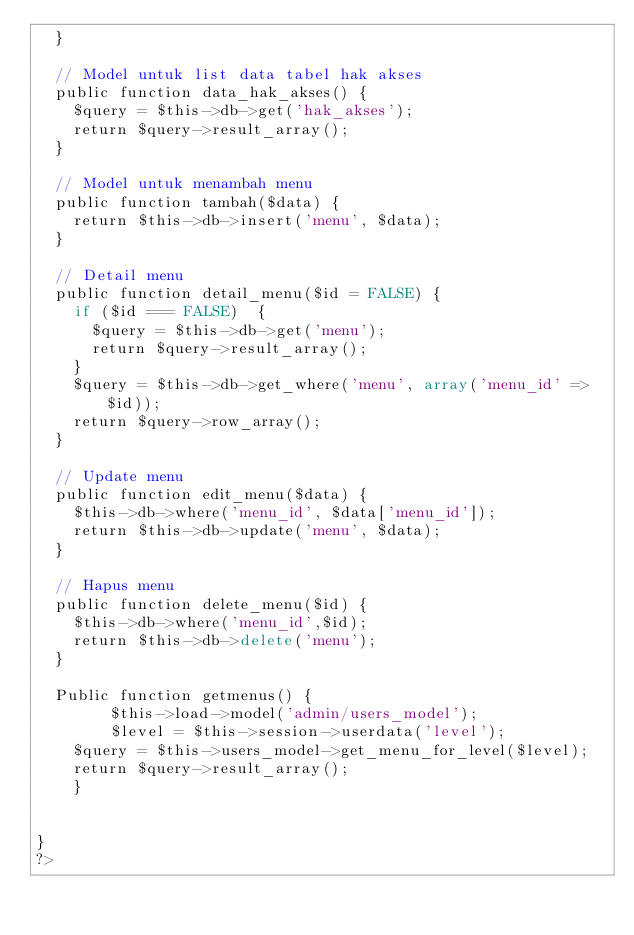Convert code to text. <code><loc_0><loc_0><loc_500><loc_500><_PHP_>	}

	// Model untuk list data tabel hak akses
	public function data_hak_akses() {
		$query = $this->db->get('hak_akses');
		return $query->result_array();
	}

	// Model untuk menambah menu
	public function tambah($data) {
		return $this->db->insert('menu', $data);
	}

	// Detail menu
	public function detail_menu($id = FALSE) {
		if ($id === FALSE)	{
			$query = $this->db->get('menu');
			return $query->result_array();
		}
		$query = $this->db->get_where('menu', array('menu_id' => $id));
		return $query->row_array();
	}
	
	// Update menu
	public function edit_menu($data) {
		$this->db->where('menu_id', $data['menu_id']);
		return $this->db->update('menu', $data);
	}
	
	// Hapus menu
	public function delete_menu($id) {
		$this->db->where('menu_id',$id);
		return $this->db->delete('menu');
	}

	Public function getmenus() {
        $this->load->model('admin/users_model');
        $level = $this->session->userdata('level');
		$query = $this->users_model->get_menu_for_level($level);
		return $query->result_array();
    }


}
?></code> 